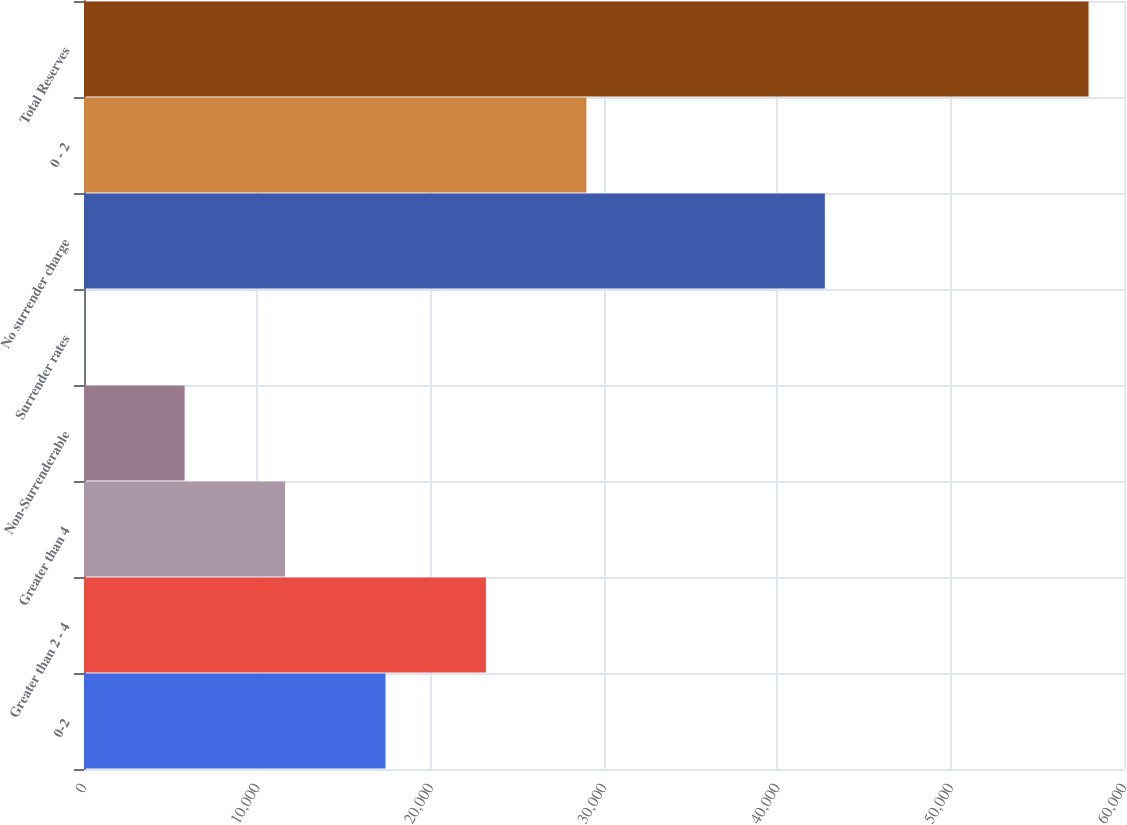Convert chart. <chart><loc_0><loc_0><loc_500><loc_500><bar_chart><fcel>0-2<fcel>Greater than 2 - 4<fcel>Greater than 4<fcel>Non-Surrenderable<fcel>Surrender rates<fcel>No surrender charge<fcel>0 - 2<fcel>Total Reserves<nl><fcel>17393.1<fcel>23187.5<fcel>11598.6<fcel>5804.22<fcel>9.8<fcel>42741<fcel>28981.9<fcel>57954<nl></chart> 